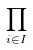<formula> <loc_0><loc_0><loc_500><loc_500>\prod _ { i \in I }</formula> 